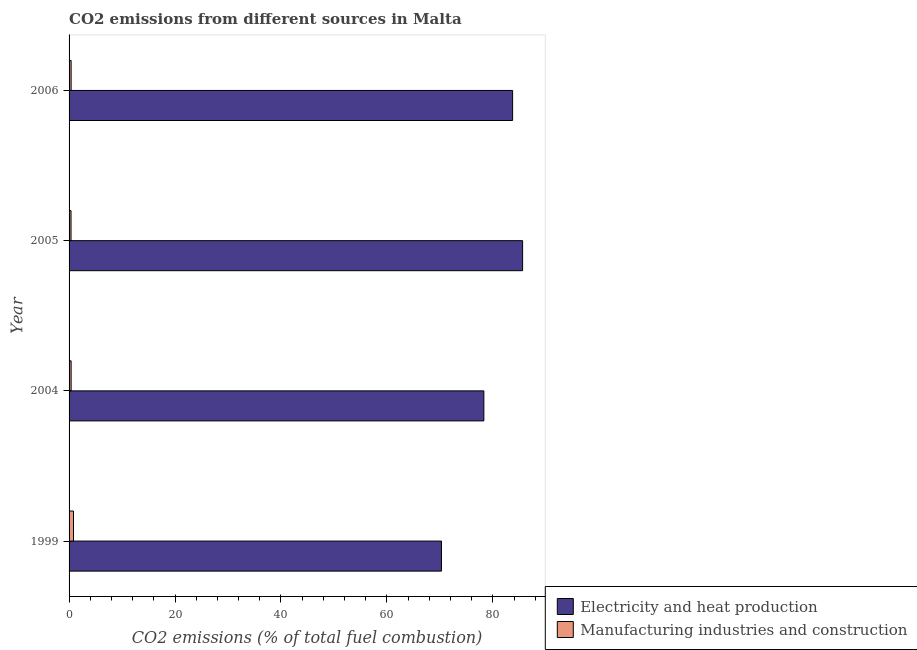How many groups of bars are there?
Your response must be concise. 4. How many bars are there on the 4th tick from the bottom?
Provide a short and direct response. 2. What is the co2 emissions due to electricity and heat production in 2006?
Ensure brevity in your answer.  83.72. Across all years, what is the maximum co2 emissions due to manufacturing industries?
Offer a very short reply. 0.84. Across all years, what is the minimum co2 emissions due to manufacturing industries?
Provide a short and direct response. 0.37. What is the total co2 emissions due to electricity and heat production in the graph?
Your answer should be very brief. 317.92. What is the difference between the co2 emissions due to manufacturing industries in 2004 and that in 2005?
Provide a short and direct response. 0.02. What is the difference between the co2 emissions due to electricity and heat production in 2004 and the co2 emissions due to manufacturing industries in 1999?
Make the answer very short. 77.46. What is the average co2 emissions due to manufacturing industries per year?
Offer a terse response. 0.49. In the year 2004, what is the difference between the co2 emissions due to manufacturing industries and co2 emissions due to electricity and heat production?
Your answer should be very brief. -77.91. In how many years, is the co2 emissions due to electricity and heat production greater than 36 %?
Offer a terse response. 4. What is the ratio of the co2 emissions due to manufacturing industries in 1999 to that in 2005?
Make the answer very short. 2.27. Is the difference between the co2 emissions due to manufacturing industries in 2004 and 2006 greater than the difference between the co2 emissions due to electricity and heat production in 2004 and 2006?
Provide a succinct answer. Yes. What is the difference between the highest and the second highest co2 emissions due to manufacturing industries?
Offer a terse response. 0.45. What is the difference between the highest and the lowest co2 emissions due to manufacturing industries?
Offer a terse response. 0.47. In how many years, is the co2 emissions due to electricity and heat production greater than the average co2 emissions due to electricity and heat production taken over all years?
Offer a terse response. 2. What does the 1st bar from the top in 2005 represents?
Ensure brevity in your answer.  Manufacturing industries and construction. What does the 1st bar from the bottom in 2004 represents?
Ensure brevity in your answer.  Electricity and heat production. How many bars are there?
Ensure brevity in your answer.  8. Are all the bars in the graph horizontal?
Provide a short and direct response. Yes. Are the values on the major ticks of X-axis written in scientific E-notation?
Ensure brevity in your answer.  No. Does the graph contain any zero values?
Offer a very short reply. No. Where does the legend appear in the graph?
Offer a terse response. Bottom right. What is the title of the graph?
Provide a short and direct response. CO2 emissions from different sources in Malta. What is the label or title of the X-axis?
Give a very brief answer. CO2 emissions (% of total fuel combustion). What is the CO2 emissions (% of total fuel combustion) in Electricity and heat production in 1999?
Provide a short and direct response. 70.29. What is the CO2 emissions (% of total fuel combustion) of Manufacturing industries and construction in 1999?
Your answer should be very brief. 0.84. What is the CO2 emissions (% of total fuel combustion) in Electricity and heat production in 2004?
Offer a terse response. 78.29. What is the CO2 emissions (% of total fuel combustion) of Manufacturing industries and construction in 2004?
Provide a short and direct response. 0.39. What is the CO2 emissions (% of total fuel combustion) of Electricity and heat production in 2005?
Provide a succinct answer. 85.61. What is the CO2 emissions (% of total fuel combustion) of Manufacturing industries and construction in 2005?
Give a very brief answer. 0.37. What is the CO2 emissions (% of total fuel combustion) of Electricity and heat production in 2006?
Provide a short and direct response. 83.72. What is the CO2 emissions (% of total fuel combustion) in Manufacturing industries and construction in 2006?
Make the answer very short. 0.39. Across all years, what is the maximum CO2 emissions (% of total fuel combustion) in Electricity and heat production?
Keep it short and to the point. 85.61. Across all years, what is the maximum CO2 emissions (% of total fuel combustion) in Manufacturing industries and construction?
Your answer should be compact. 0.84. Across all years, what is the minimum CO2 emissions (% of total fuel combustion) in Electricity and heat production?
Your answer should be compact. 70.29. Across all years, what is the minimum CO2 emissions (% of total fuel combustion) in Manufacturing industries and construction?
Your response must be concise. 0.37. What is the total CO2 emissions (% of total fuel combustion) in Electricity and heat production in the graph?
Your answer should be very brief. 317.92. What is the total CO2 emissions (% of total fuel combustion) of Manufacturing industries and construction in the graph?
Give a very brief answer. 1.98. What is the difference between the CO2 emissions (% of total fuel combustion) of Electricity and heat production in 1999 and that in 2004?
Offer a terse response. -8. What is the difference between the CO2 emissions (% of total fuel combustion) in Manufacturing industries and construction in 1999 and that in 2004?
Offer a very short reply. 0.45. What is the difference between the CO2 emissions (% of total fuel combustion) of Electricity and heat production in 1999 and that in 2005?
Give a very brief answer. -15.32. What is the difference between the CO2 emissions (% of total fuel combustion) in Manufacturing industries and construction in 1999 and that in 2005?
Give a very brief answer. 0.47. What is the difference between the CO2 emissions (% of total fuel combustion) in Electricity and heat production in 1999 and that in 2006?
Provide a short and direct response. -13.43. What is the difference between the CO2 emissions (% of total fuel combustion) of Manufacturing industries and construction in 1999 and that in 2006?
Your answer should be very brief. 0.45. What is the difference between the CO2 emissions (% of total fuel combustion) of Electricity and heat production in 2004 and that in 2005?
Your answer should be very brief. -7.31. What is the difference between the CO2 emissions (% of total fuel combustion) of Manufacturing industries and construction in 2004 and that in 2005?
Offer a very short reply. 0.02. What is the difference between the CO2 emissions (% of total fuel combustion) of Electricity and heat production in 2004 and that in 2006?
Ensure brevity in your answer.  -5.43. What is the difference between the CO2 emissions (% of total fuel combustion) of Manufacturing industries and construction in 2004 and that in 2006?
Provide a succinct answer. 0. What is the difference between the CO2 emissions (% of total fuel combustion) of Electricity and heat production in 2005 and that in 2006?
Make the answer very short. 1.89. What is the difference between the CO2 emissions (% of total fuel combustion) in Manufacturing industries and construction in 2005 and that in 2006?
Your response must be concise. -0.02. What is the difference between the CO2 emissions (% of total fuel combustion) of Electricity and heat production in 1999 and the CO2 emissions (% of total fuel combustion) of Manufacturing industries and construction in 2004?
Provide a succinct answer. 69.91. What is the difference between the CO2 emissions (% of total fuel combustion) in Electricity and heat production in 1999 and the CO2 emissions (% of total fuel combustion) in Manufacturing industries and construction in 2005?
Ensure brevity in your answer.  69.92. What is the difference between the CO2 emissions (% of total fuel combustion) in Electricity and heat production in 1999 and the CO2 emissions (% of total fuel combustion) in Manufacturing industries and construction in 2006?
Provide a succinct answer. 69.91. What is the difference between the CO2 emissions (% of total fuel combustion) of Electricity and heat production in 2004 and the CO2 emissions (% of total fuel combustion) of Manufacturing industries and construction in 2005?
Your response must be concise. 77.93. What is the difference between the CO2 emissions (% of total fuel combustion) of Electricity and heat production in 2004 and the CO2 emissions (% of total fuel combustion) of Manufacturing industries and construction in 2006?
Make the answer very short. 77.91. What is the difference between the CO2 emissions (% of total fuel combustion) of Electricity and heat production in 2005 and the CO2 emissions (% of total fuel combustion) of Manufacturing industries and construction in 2006?
Offer a terse response. 85.22. What is the average CO2 emissions (% of total fuel combustion) of Electricity and heat production per year?
Your response must be concise. 79.48. What is the average CO2 emissions (% of total fuel combustion) of Manufacturing industries and construction per year?
Your answer should be very brief. 0.5. In the year 1999, what is the difference between the CO2 emissions (% of total fuel combustion) in Electricity and heat production and CO2 emissions (% of total fuel combustion) in Manufacturing industries and construction?
Make the answer very short. 69.46. In the year 2004, what is the difference between the CO2 emissions (% of total fuel combustion) of Electricity and heat production and CO2 emissions (% of total fuel combustion) of Manufacturing industries and construction?
Ensure brevity in your answer.  77.91. In the year 2005, what is the difference between the CO2 emissions (% of total fuel combustion) in Electricity and heat production and CO2 emissions (% of total fuel combustion) in Manufacturing industries and construction?
Provide a succinct answer. 85.24. In the year 2006, what is the difference between the CO2 emissions (% of total fuel combustion) in Electricity and heat production and CO2 emissions (% of total fuel combustion) in Manufacturing industries and construction?
Provide a short and direct response. 83.33. What is the ratio of the CO2 emissions (% of total fuel combustion) in Electricity and heat production in 1999 to that in 2004?
Your answer should be compact. 0.9. What is the ratio of the CO2 emissions (% of total fuel combustion) of Manufacturing industries and construction in 1999 to that in 2004?
Offer a very short reply. 2.16. What is the ratio of the CO2 emissions (% of total fuel combustion) of Electricity and heat production in 1999 to that in 2005?
Make the answer very short. 0.82. What is the ratio of the CO2 emissions (% of total fuel combustion) in Manufacturing industries and construction in 1999 to that in 2005?
Offer a very short reply. 2.27. What is the ratio of the CO2 emissions (% of total fuel combustion) of Electricity and heat production in 1999 to that in 2006?
Your answer should be very brief. 0.84. What is the ratio of the CO2 emissions (% of total fuel combustion) of Manufacturing industries and construction in 1999 to that in 2006?
Offer a very short reply. 2.16. What is the ratio of the CO2 emissions (% of total fuel combustion) of Electricity and heat production in 2004 to that in 2005?
Your answer should be very brief. 0.91. What is the ratio of the CO2 emissions (% of total fuel combustion) of Manufacturing industries and construction in 2004 to that in 2005?
Offer a very short reply. 1.05. What is the ratio of the CO2 emissions (% of total fuel combustion) of Electricity and heat production in 2004 to that in 2006?
Your answer should be compact. 0.94. What is the ratio of the CO2 emissions (% of total fuel combustion) in Manufacturing industries and construction in 2004 to that in 2006?
Ensure brevity in your answer.  1. What is the ratio of the CO2 emissions (% of total fuel combustion) in Electricity and heat production in 2005 to that in 2006?
Provide a short and direct response. 1.02. What is the difference between the highest and the second highest CO2 emissions (% of total fuel combustion) of Electricity and heat production?
Your answer should be very brief. 1.89. What is the difference between the highest and the second highest CO2 emissions (% of total fuel combustion) of Manufacturing industries and construction?
Your response must be concise. 0.45. What is the difference between the highest and the lowest CO2 emissions (% of total fuel combustion) of Electricity and heat production?
Your response must be concise. 15.32. What is the difference between the highest and the lowest CO2 emissions (% of total fuel combustion) in Manufacturing industries and construction?
Offer a terse response. 0.47. 